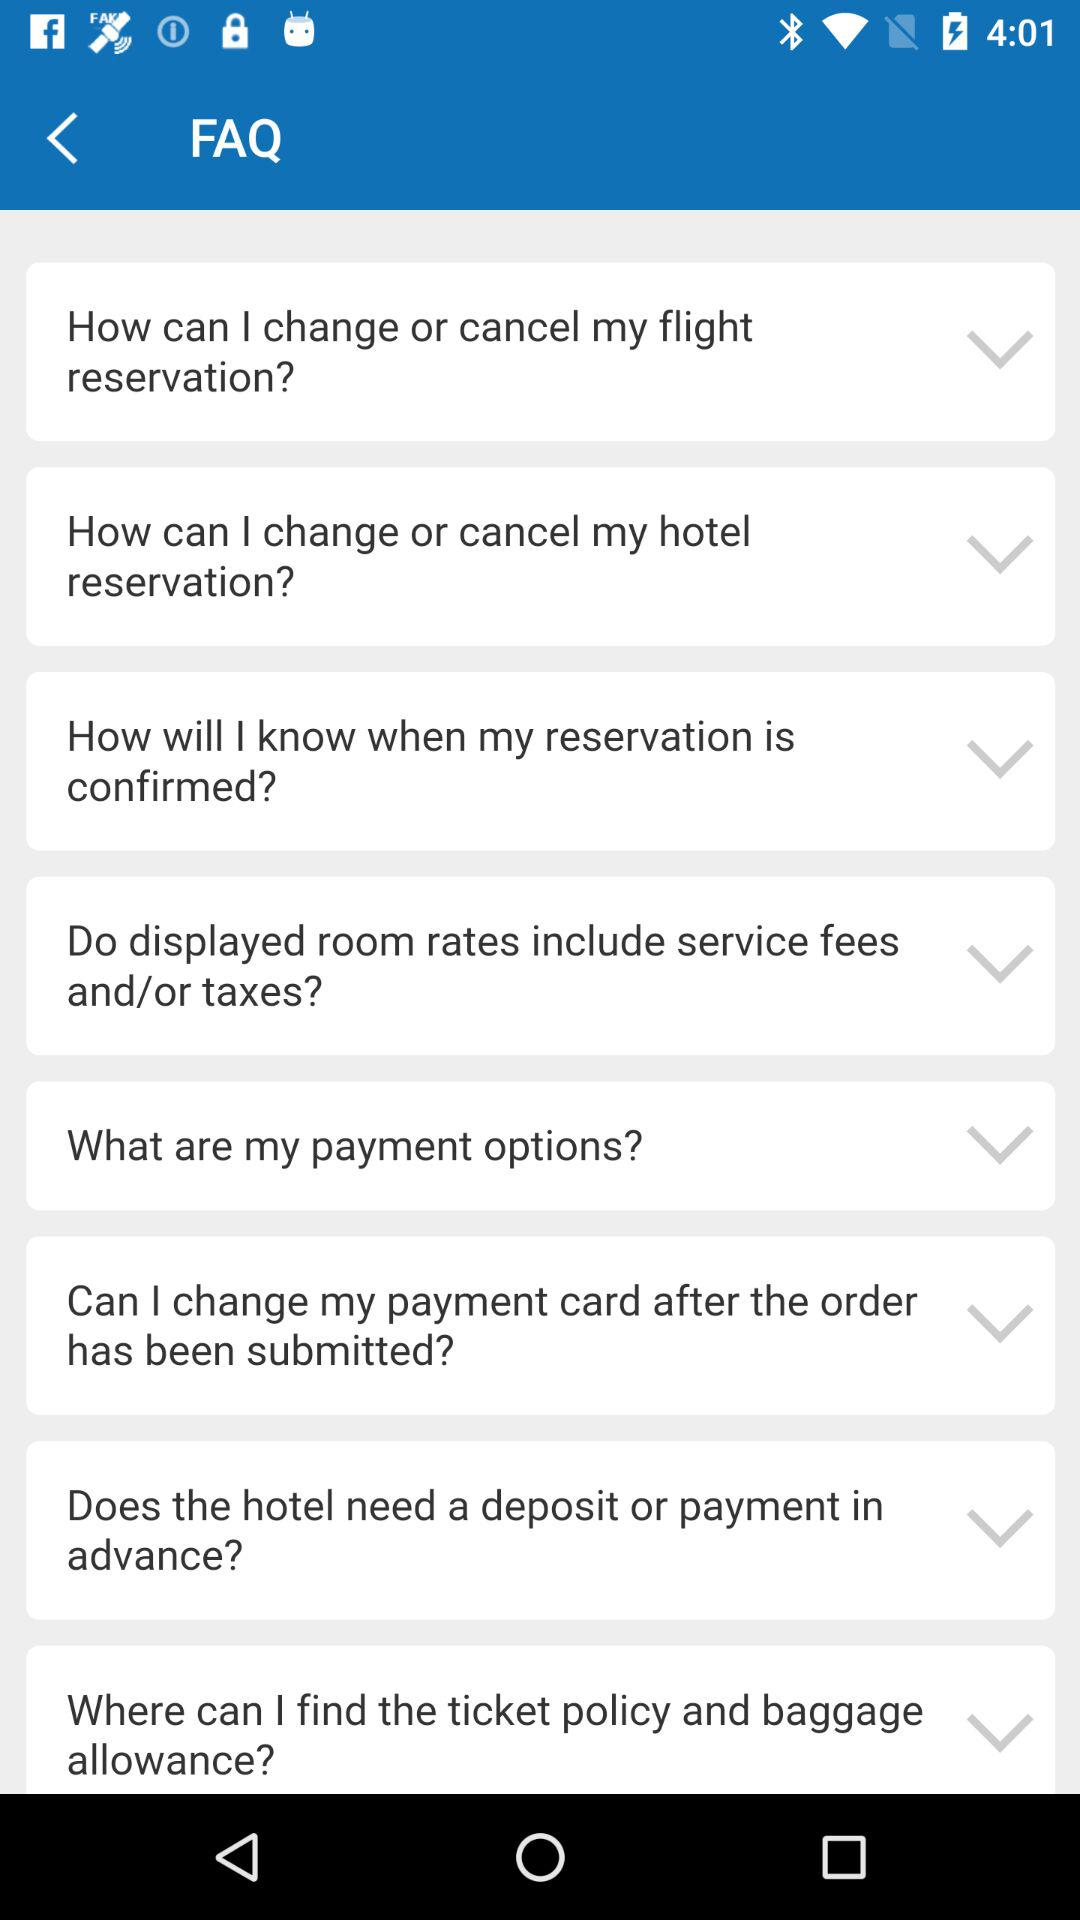How many FAQs are there in total?
Answer the question using a single word or phrase. 8 